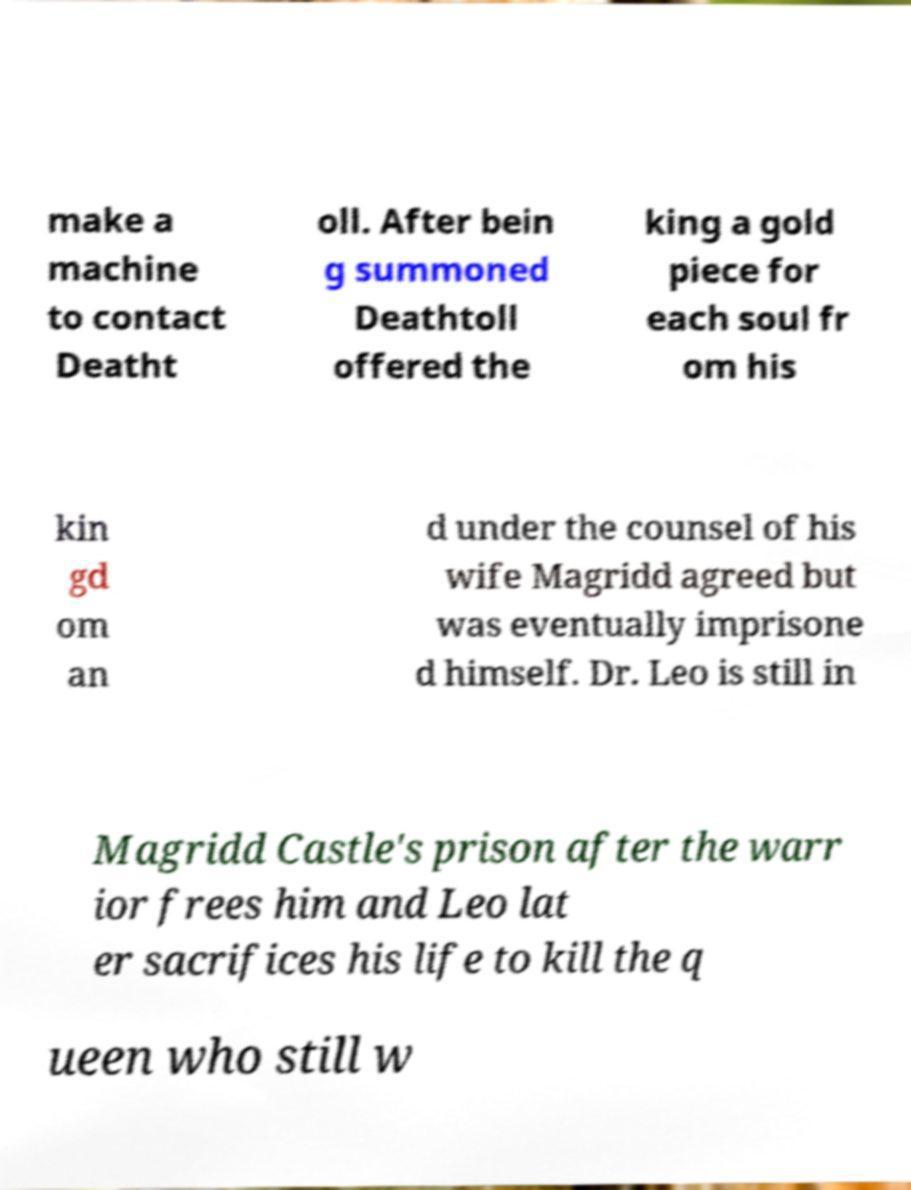Could you extract and type out the text from this image? make a machine to contact Deatht oll. After bein g summoned Deathtoll offered the king a gold piece for each soul fr om his kin gd om an d under the counsel of his wife Magridd agreed but was eventually imprisone d himself. Dr. Leo is still in Magridd Castle's prison after the warr ior frees him and Leo lat er sacrifices his life to kill the q ueen who still w 